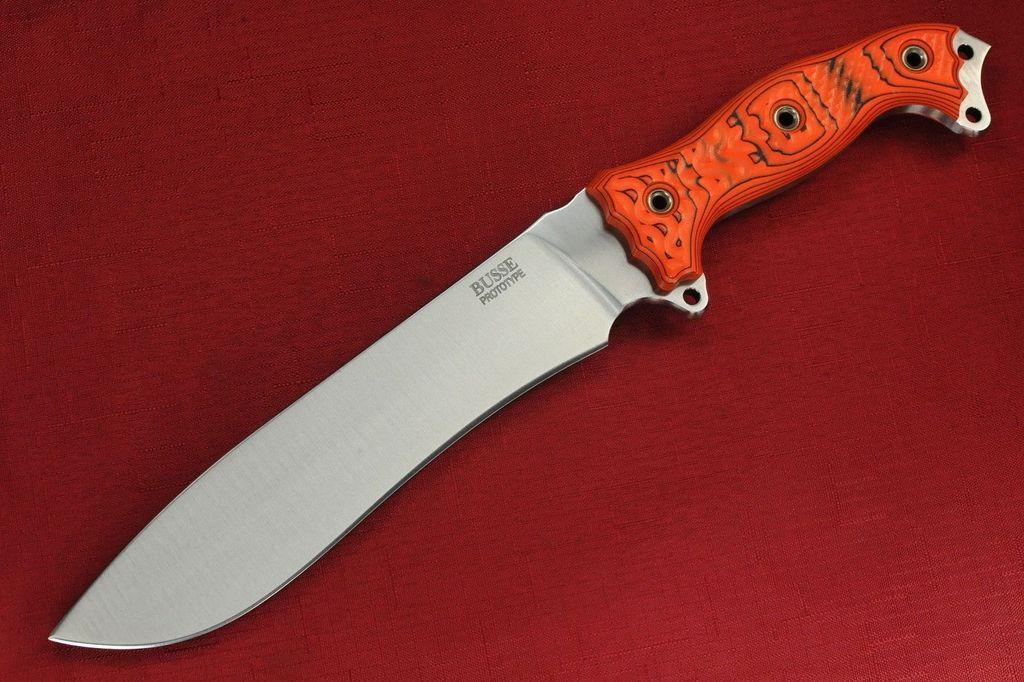How would you summarize this image in a sentence or two? In this image we can see a knife on the table with a red cloth. 